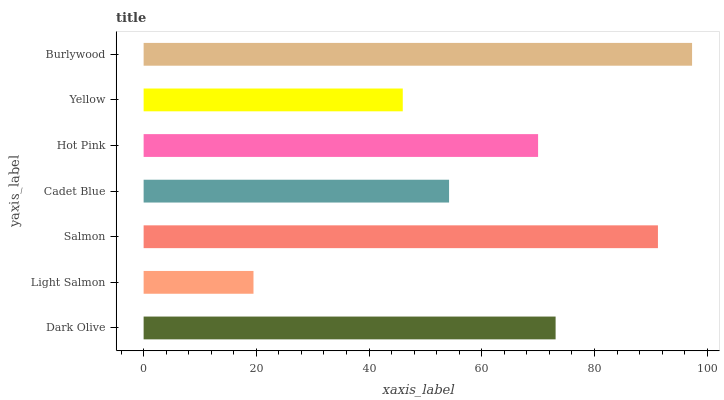Is Light Salmon the minimum?
Answer yes or no. Yes. Is Burlywood the maximum?
Answer yes or no. Yes. Is Salmon the minimum?
Answer yes or no. No. Is Salmon the maximum?
Answer yes or no. No. Is Salmon greater than Light Salmon?
Answer yes or no. Yes. Is Light Salmon less than Salmon?
Answer yes or no. Yes. Is Light Salmon greater than Salmon?
Answer yes or no. No. Is Salmon less than Light Salmon?
Answer yes or no. No. Is Hot Pink the high median?
Answer yes or no. Yes. Is Hot Pink the low median?
Answer yes or no. Yes. Is Salmon the high median?
Answer yes or no. No. Is Salmon the low median?
Answer yes or no. No. 